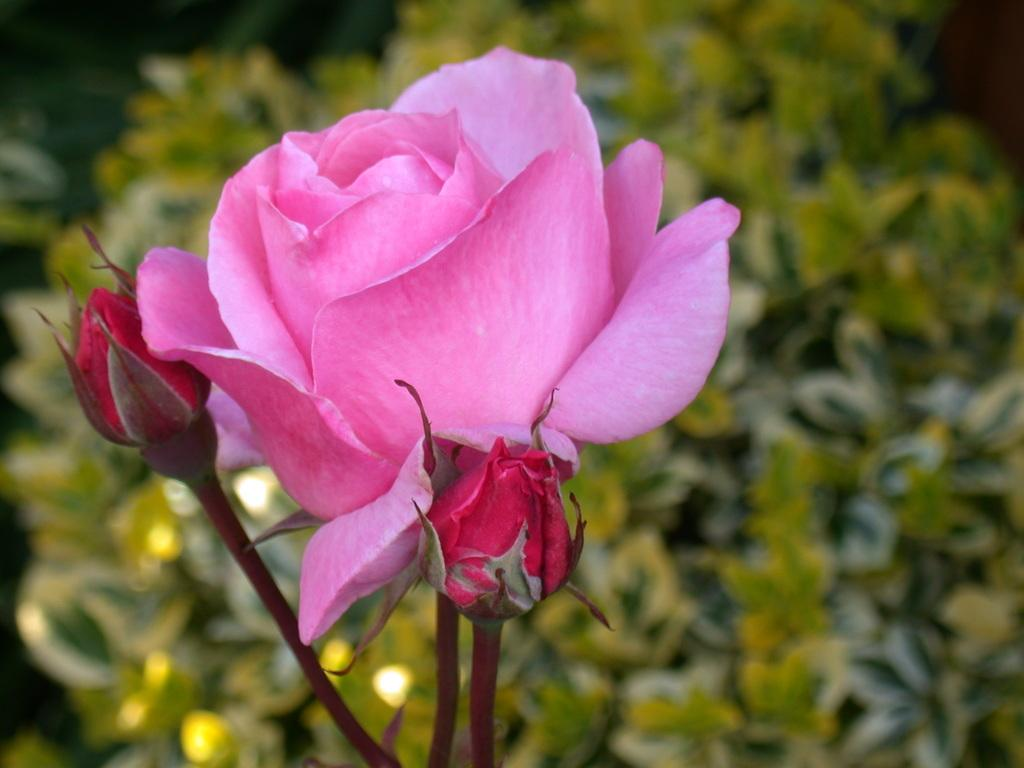What type of flower is in the image? There is a rose flower in the image. How many buds are present on the stems of the rose flower? There are two buds on the stems of the rose flower. What else can be seen in the background of the image? There are leaves visible in the background of the image. What type of club is depicted in the image? There is no club present in the image; it features a rose flower with buds and leaves in the background. Is there a crown visible on the rose flower in the image? No, there is no crown present on the rose flower in the image. 